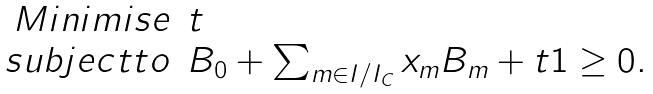<formula> <loc_0><loc_0><loc_500><loc_500>\begin{array} { r l } M i n i m i s e & t \\ s u b j e c t t o & B _ { 0 } + \sum _ { m \in I / I _ { C } } x _ { m } B _ { m } + t 1 \geq 0 . \end{array}</formula> 